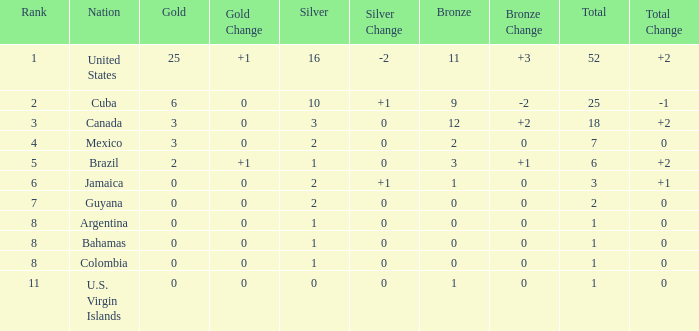What is the fewest number of silver medals a nation who ranked below 8 received? 0.0. 